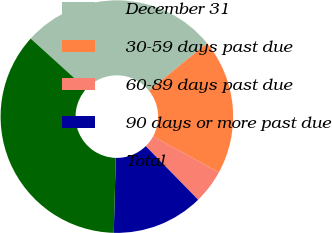Convert chart to OTSL. <chart><loc_0><loc_0><loc_500><loc_500><pie_chart><fcel>December 31<fcel>30-59 days past due<fcel>60-89 days past due<fcel>90 days or more past due<fcel>Total<nl><fcel>27.42%<fcel>18.82%<fcel>4.72%<fcel>12.74%<fcel>36.29%<nl></chart> 